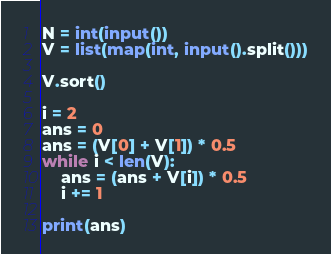<code> <loc_0><loc_0><loc_500><loc_500><_Python_>N = int(input())
V = list(map(int, input().split()))

V.sort()

i = 2
ans = 0
ans = (V[0] + V[1]) * 0.5
while i < len(V):
    ans = (ans + V[i]) * 0.5
    i += 1

print(ans)
</code> 